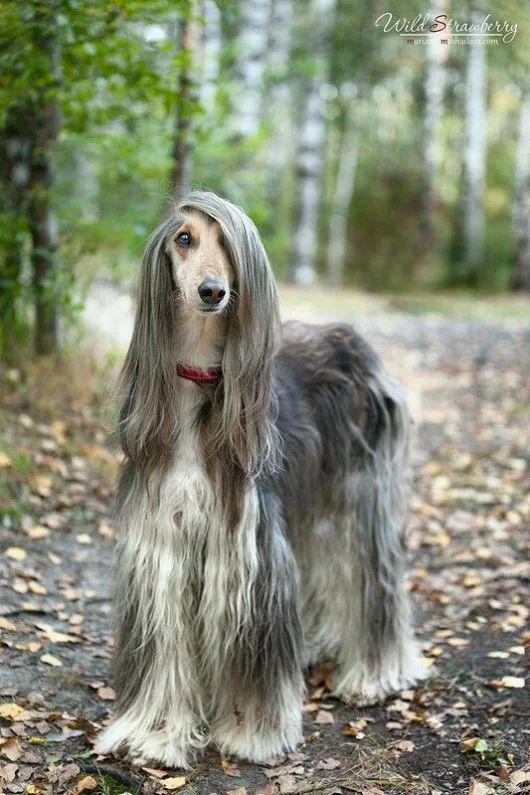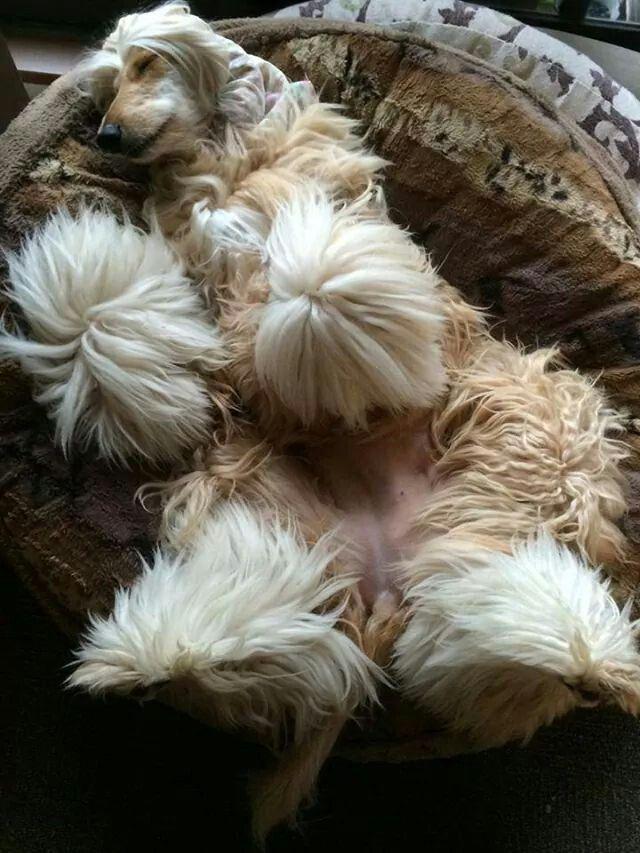The first image is the image on the left, the second image is the image on the right. For the images shown, is this caption "One dog is standing and one dog is laying down." true? Answer yes or no. Yes. The first image is the image on the left, the second image is the image on the right. Evaluate the accuracy of this statement regarding the images: "One image shows a single afghan hound lying on a soft material with a print pattern in the scene, and the other image shows one forward-facing afghan with parted hair.". Is it true? Answer yes or no. Yes. 